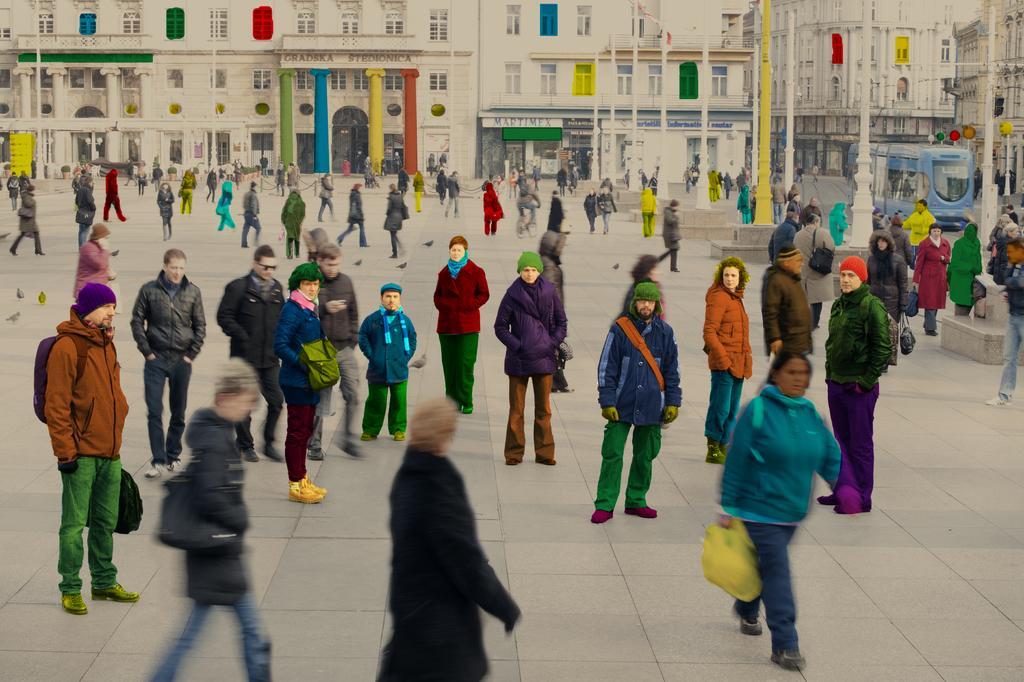In one or two sentences, can you explain what this image depicts? In this image we can see few persons are standing and walking on the road and among them few persons are carrying bags on their shoulders and holding bags in their hands. In the background we can see few persons are walking on the road, vehicle on the right side, buildings, poles, windows, pillars, hoardings on the walls and other objects. 